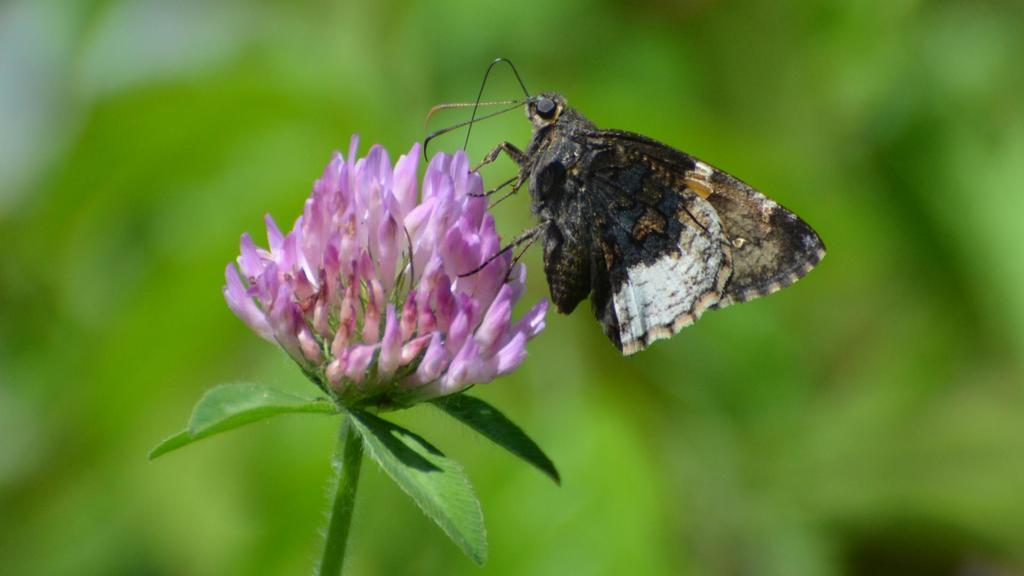What is the main subject of the picture? The main subject of the picture is a butterfly. Where is the butterfly located in the image? The butterfly is on a flower. Can you describe the background of the image? The background of the image is blurry. What type of wool is being used to create the garden in the image? There is no wool or garden present in the image; it features a butterfly on a flower with a blurry background. 